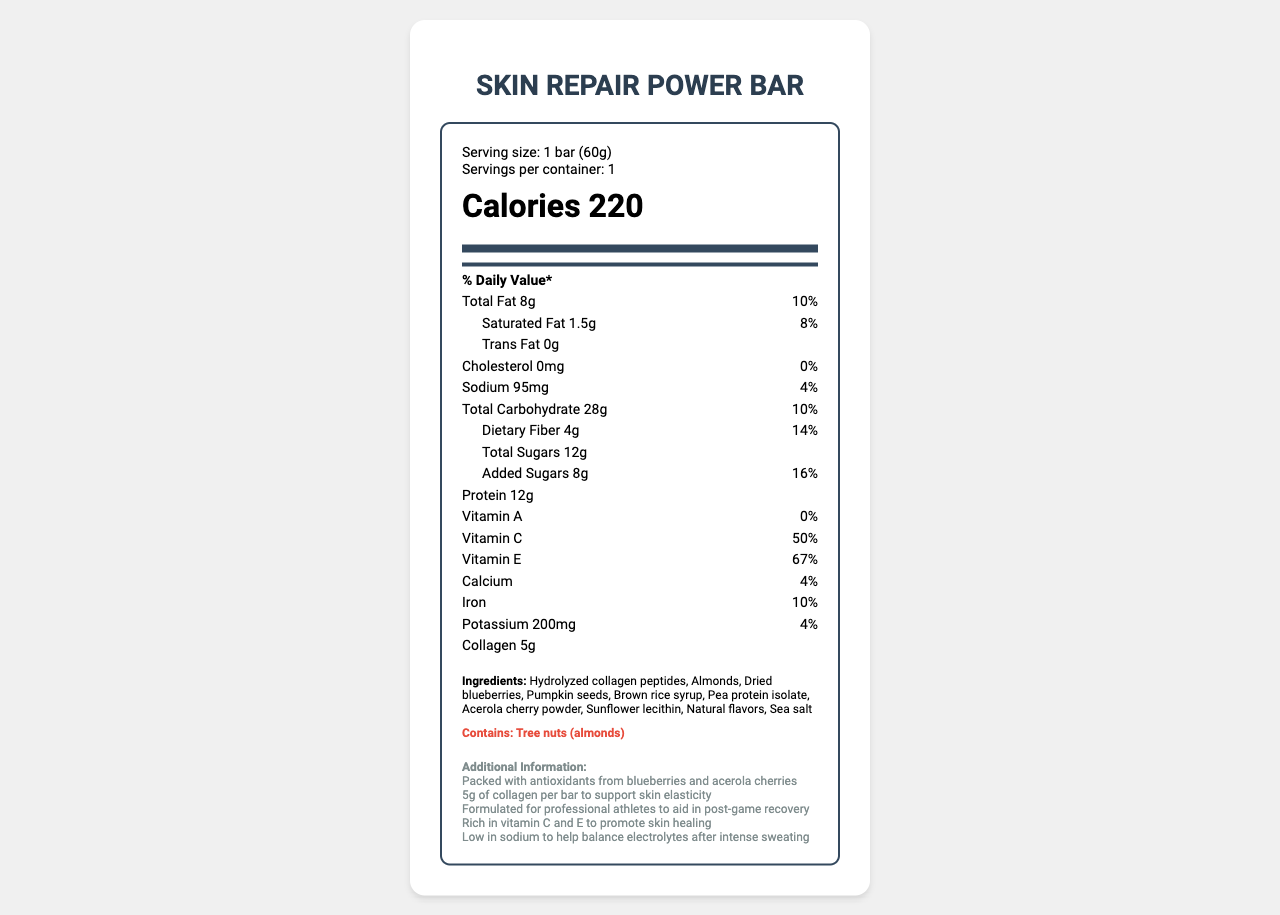what is the serving size for the Skin Repair Power Bar? The serving size is stated as "1 bar (60g)" under the serving information section.
Answer: 1 bar (60g) how many grams of total fat does the Skin Repair Power Bar contain? The total fat content is listed as "8g" in the nutrients section.
Answer: 8g what is the daily value percentage of vitamin C in the Skin Repair Power Bar? The document states that the daily value percentage of vitamin C is "50%".
Answer: 50% how much protein is in the Skin Repair Power Bar? The protein content is mentioned as "12g" in the nutrient listing.
Answer: 12g how many milligrams of potassium are in the Skin Repair Power Bar? The potassium amount is given as "200mg" in the nutrient section.
Answer: 200mg how much collagen is in one bar of the Skin Repair Power Bar? A. 3g B. 4g C. 5g D. 6g The amount of collagen per bar is listed as "5g".
Answer: C which ingredient in the Skin Repair Power Bar helps to support skin elasticity? A. Almonds B. Hydrolyzed collagen peptides C. Pumpkin seeds The additional information states that the bar contains "5g of collagen per bar to support skin elasticity".
Answer: B does the Skin Repair Power Bar contain any tree nuts? The allergens section specifies that the bar "Contains: Tree nuts (almonds)".
Answer: Yes is the Skin Repair Power Bar low in sodium? The additional information mentions that the bar is "Low in sodium to help balance electrolytes after intense sweating".
Answer: Yes summarize the key features and nutritional highlights of the Skin Repair Power Bar. The summary is derived by compiling the details from the serving size, nutritional data, ingredients, allergens, and additional information sections.
Answer: The Skin Repair Power Bar is a post-game recovery snack designed for professional athletes. It has a serving size of 1 bar (60g) with 220 calories. It contains 8g of total fat, 12g protein, 5g collagen, and is rich in vitamins C and E, which promote skin healing and elasticity. The bar includes ingredients such as hydrolyzed collagen peptides, almonds, dried blueberries, and pumpkin seeds, and contains tree nuts (almonds). It is also low in sodium and packed with antioxidants. what is the sugar content in the Skin Repair Power Bar from added sugars? The added sugars amount is mentioned as "8g" in the nutrient details.
Answer: 8g what is the percentage of dietary fiber compared to the daily recommended intake? The daily value percentage of dietary fiber is listed as "14%" in the nutrient section.
Answer: 14% how many servings are there in one container? The serving information at the top mentions "Servings per container: 1".
Answer: 1 can the exact amount of sunflower lecithin in the Skin Repair Power Bar be determined from the document? The exact amount of sunflower lecithin is not specified in the ingredients list or the nutritional information.
Answer: Cannot be determined how many calories are in the Skin Repair Power Bar? The calorie count is listed as "220" in the prominent calories section of the label.
Answer: 220 